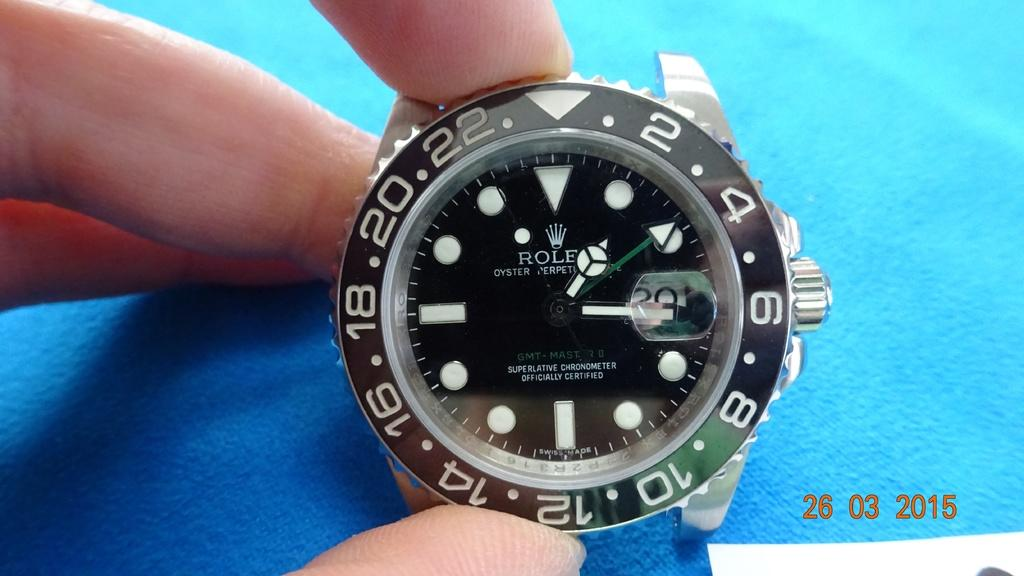<image>
Share a concise interpretation of the image provided. A Rolex watch has a black face and white numbers. 